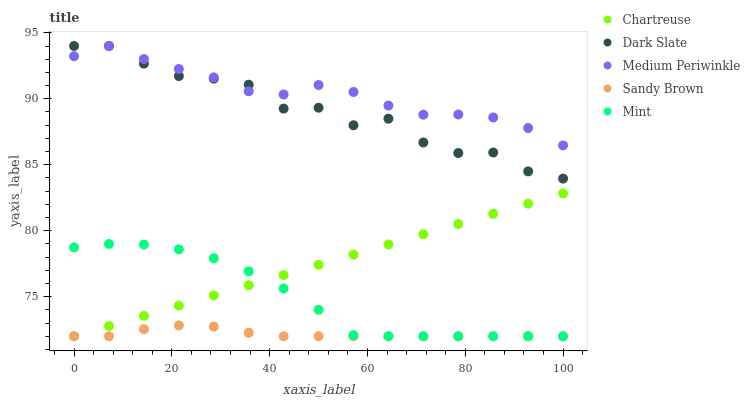Does Sandy Brown have the minimum area under the curve?
Answer yes or no. Yes. Does Medium Periwinkle have the maximum area under the curve?
Answer yes or no. Yes. Does Chartreuse have the minimum area under the curve?
Answer yes or no. No. Does Chartreuse have the maximum area under the curve?
Answer yes or no. No. Is Chartreuse the smoothest?
Answer yes or no. Yes. Is Dark Slate the roughest?
Answer yes or no. Yes. Is Medium Periwinkle the smoothest?
Answer yes or no. No. Is Medium Periwinkle the roughest?
Answer yes or no. No. Does Chartreuse have the lowest value?
Answer yes or no. Yes. Does Medium Periwinkle have the lowest value?
Answer yes or no. No. Does Medium Periwinkle have the highest value?
Answer yes or no. Yes. Does Chartreuse have the highest value?
Answer yes or no. No. Is Mint less than Medium Periwinkle?
Answer yes or no. Yes. Is Dark Slate greater than Mint?
Answer yes or no. Yes. Does Chartreuse intersect Mint?
Answer yes or no. Yes. Is Chartreuse less than Mint?
Answer yes or no. No. Is Chartreuse greater than Mint?
Answer yes or no. No. Does Mint intersect Medium Periwinkle?
Answer yes or no. No. 